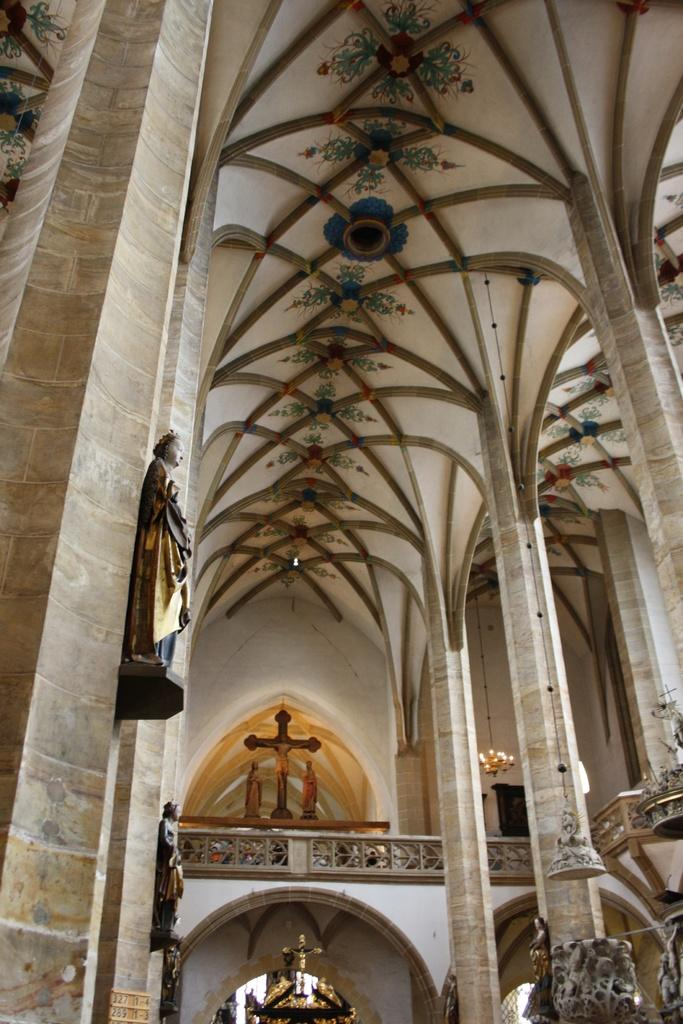Where is the setting of the image? The image is inside a building. What architectural features can be seen in the image? There are pillars and a wooden railing in the image. What religious symbol is present in the image? There is a cross in the image. What type of artwork is visible in the image? There are sculptures and paintings with decorations on the ceiling in the image. What lighting fixture is present in the image? There is a chandelier in the image. What type of jelly can be seen on the sculptures in the image? There is no jelly present on the sculptures in the image. How does the taste of the paintings with decorations on the ceiling compare to the chandelier? The paintings and chandelier are not edible, so they cannot be tasted. 